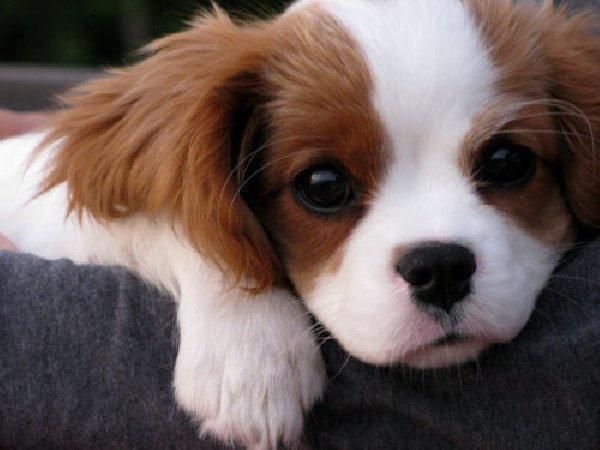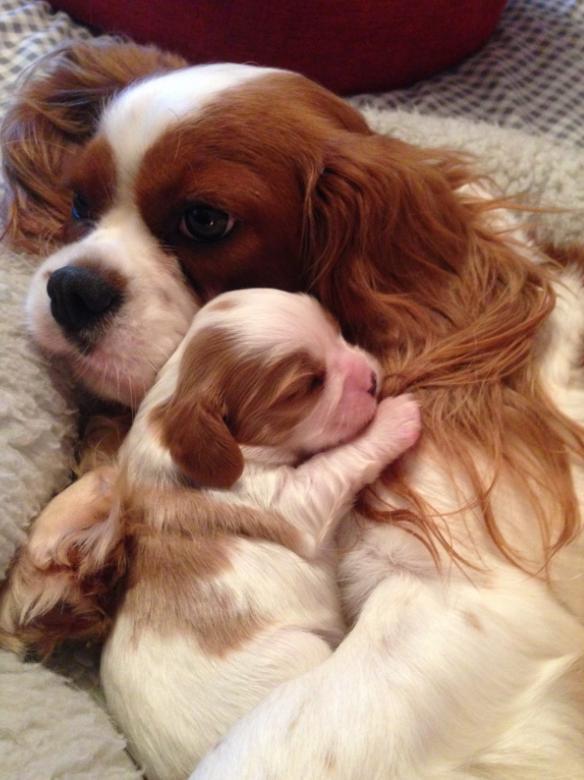The first image is the image on the left, the second image is the image on the right. Examine the images to the left and right. Is the description "All the dogs are lying down and one dog has its head facing towards the left side of the image." accurate? Answer yes or no. Yes. The first image is the image on the left, the second image is the image on the right. Analyze the images presented: Is the assertion "There are two dogs, one that is looking forward and one that is not." valid? Answer yes or no. No. 